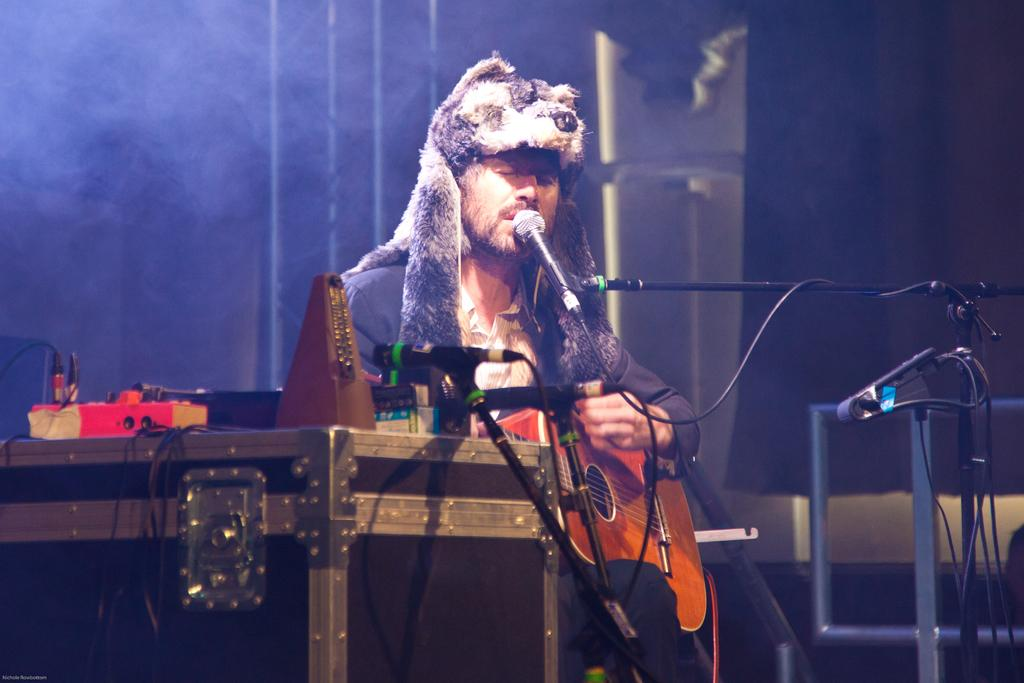What is the man in the image doing? The man is sitting, playing a guitar, singing a song, and using a microphone. What instrument is the man playing in the image? The man is playing a guitar in the image. What is the man using to amplify his voice in the image? The man is using a microphone in the image. What can be seen in the background of the image? There are cables and a briefcase in the background of the image. What type of pie is the man eating in the image? There is no pie present in the image; the man is playing a guitar, singing, and using a microphone. 